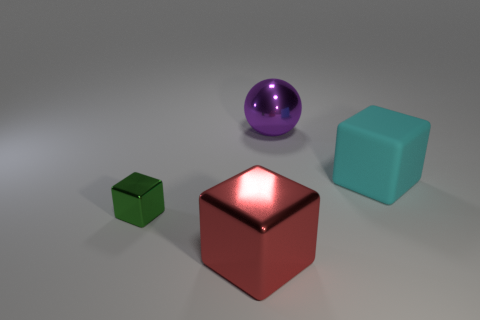Do the green metal thing and the cyan matte object have the same size?
Your answer should be compact. No. Are there any other things that have the same shape as the small metal object?
Offer a very short reply. Yes. Is the small block made of the same material as the big cube in front of the rubber cube?
Provide a short and direct response. Yes. Is the color of the large block to the left of the big ball the same as the big sphere?
Offer a very short reply. No. How many big objects are in front of the large cyan rubber thing and behind the rubber cube?
Your response must be concise. 0. How many other objects are the same material as the cyan thing?
Ensure brevity in your answer.  0. Do the big cube in front of the small metal block and the tiny green block have the same material?
Offer a very short reply. Yes. How big is the metallic object that is behind the cyan rubber block that is behind the big object in front of the large cyan matte block?
Keep it short and to the point. Large. What number of other objects are there of the same color as the ball?
Ensure brevity in your answer.  0. What is the shape of the red object that is the same size as the cyan rubber cube?
Provide a short and direct response. Cube. 